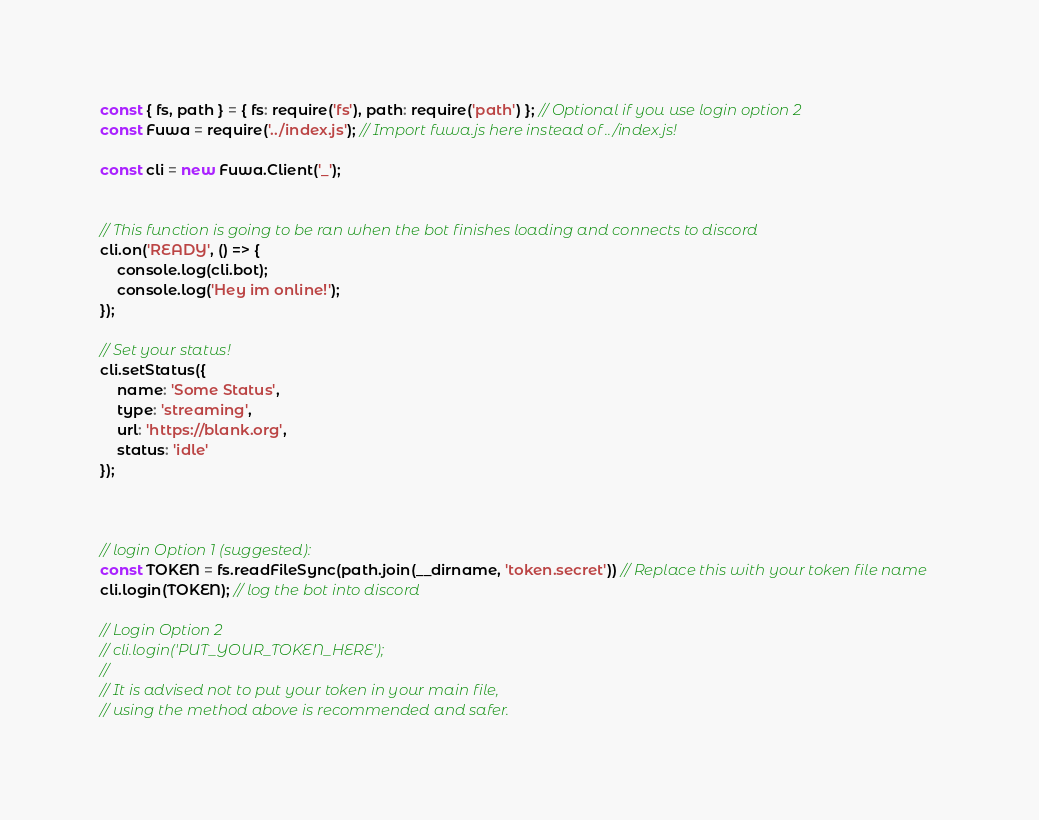<code> <loc_0><loc_0><loc_500><loc_500><_JavaScript_>const { fs, path } = { fs: require('fs'), path: require('path') }; // Optional if you use login option 2
const Fuwa = require('../index.js'); // Import fuwa.js here instead of ../index.js!

const cli = new Fuwa.Client('_');


// This function is going to be ran when the bot finishes loading and connects to discord
cli.on('READY', () => {
    console.log(cli.bot);
    console.log('Hey im online!');
});

// Set your status!
cli.setStatus({
    name: 'Some Status', 
    type: 'streaming',
    url: 'https://blank.org',
    status: 'idle' 
});



// login Option 1 (suggested):
const TOKEN = fs.readFileSync(path.join(__dirname, 'token.secret')) // Replace this with your token file name
cli.login(TOKEN); // log the bot into discord

// Login Option 2
// cli.login('PUT_YOUR_TOKEN_HERE');
//
// It is advised not to put your token in your main file, 
// using the method above is recommended and safer.

</code> 